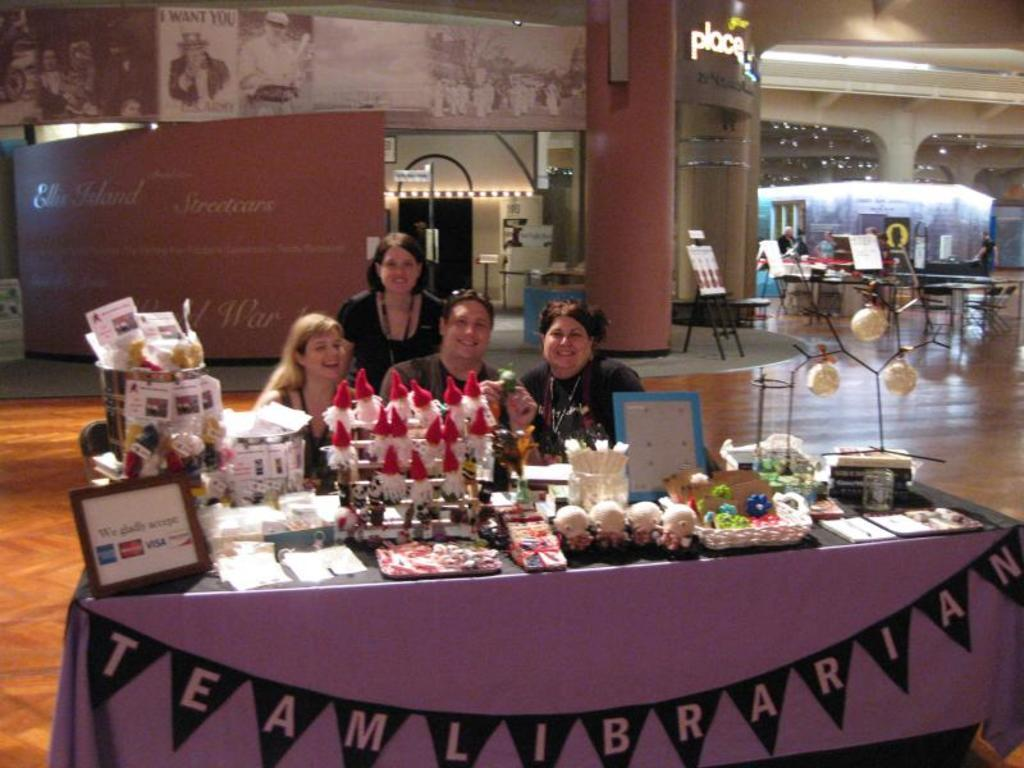How many people are in the image? There are four people in the image. What is the location of the people in the image? The people are near a table. What is written on the table? The table has the words "TEAM LIBRARIAN" written on it. What can be seen in the background of the image? There are empty tables and a decorated wall in the background of the image. Can you see any cows in the image? No, there are no cows present in the image. What type of sand can be seen on the floor in the image? There is no sand visible in the image; it appears to be an indoor setting with a floor surface other than sand. 